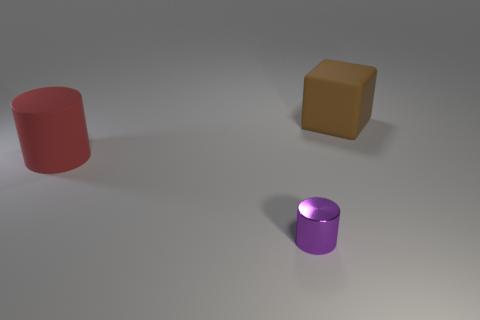Is there anything else that is the same shape as the purple metallic object?
Provide a short and direct response. Yes. Is the number of red cylinders in front of the purple object the same as the number of small brown shiny cubes?
Offer a very short reply. Yes. There is a small metallic thing; is it the same color as the large thing that is behind the large red cylinder?
Give a very brief answer. No. There is a object that is both in front of the big brown object and behind the small thing; what color is it?
Provide a succinct answer. Red. What number of big rubber things are behind the rubber object that is in front of the large brown rubber block?
Ensure brevity in your answer.  1. Is there another purple thing of the same shape as the purple thing?
Your answer should be compact. No. There is a big matte thing that is left of the purple metal cylinder; is its shape the same as the thing in front of the big red rubber cylinder?
Offer a very short reply. Yes. What number of objects are either brown matte things or large green rubber cylinders?
Keep it short and to the point. 1. The purple thing that is the same shape as the red thing is what size?
Your answer should be compact. Small. Is the number of red cylinders that are in front of the big brown object greater than the number of large blue things?
Ensure brevity in your answer.  Yes. 